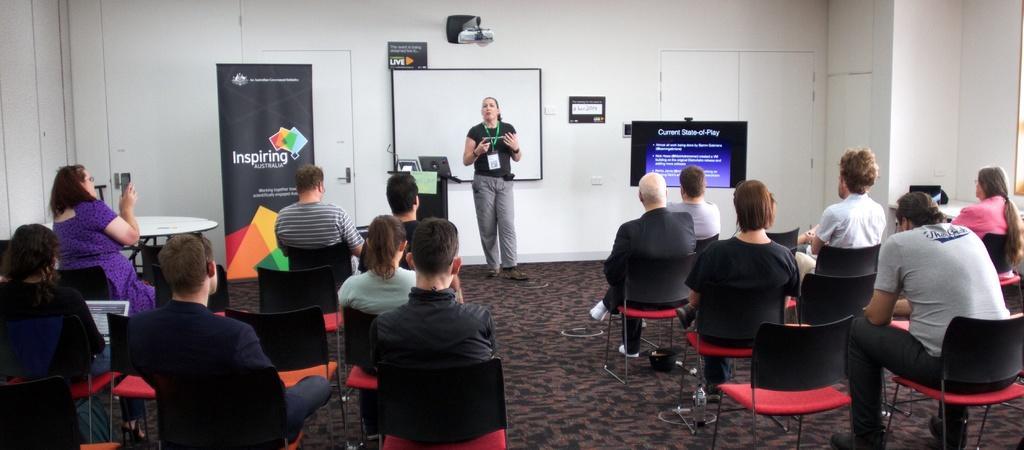Please provide a concise description of this image. In this image we can see these people are sitting on the chairs. This woman standing is teaching. This is the podium on which laptop is placed. This is the white board, projector, monitor and banner. 